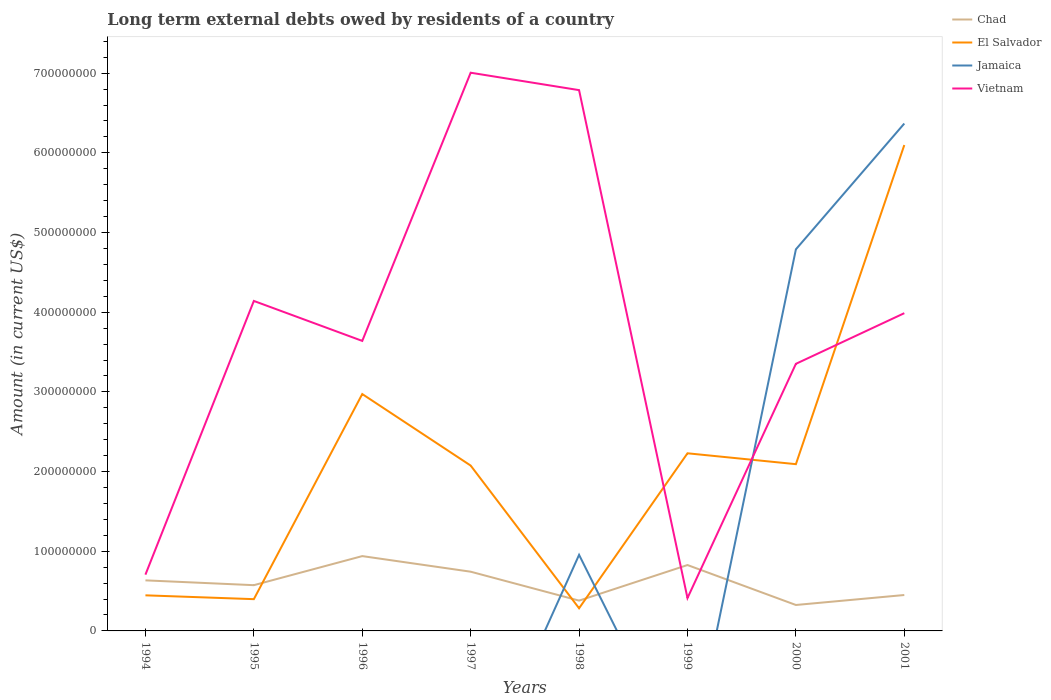How many different coloured lines are there?
Give a very brief answer. 4. Does the line corresponding to Jamaica intersect with the line corresponding to Chad?
Your answer should be very brief. Yes. Is the number of lines equal to the number of legend labels?
Keep it short and to the point. No. What is the total amount of long-term external debts owed by residents in El Salvador in the graph?
Your answer should be very brief. 7.43e+07. What is the difference between the highest and the second highest amount of long-term external debts owed by residents in Vietnam?
Provide a succinct answer. 6.59e+08. Is the amount of long-term external debts owed by residents in Jamaica strictly greater than the amount of long-term external debts owed by residents in El Salvador over the years?
Your answer should be compact. No. How many lines are there?
Offer a terse response. 4. How many years are there in the graph?
Offer a very short reply. 8. What is the difference between two consecutive major ticks on the Y-axis?
Your answer should be very brief. 1.00e+08. Does the graph contain any zero values?
Offer a terse response. Yes. Does the graph contain grids?
Make the answer very short. No. How are the legend labels stacked?
Make the answer very short. Vertical. What is the title of the graph?
Offer a terse response. Long term external debts owed by residents of a country. Does "Macedonia" appear as one of the legend labels in the graph?
Your answer should be very brief. No. What is the Amount (in current US$) of Chad in 1994?
Your answer should be very brief. 6.35e+07. What is the Amount (in current US$) in El Salvador in 1994?
Offer a very short reply. 4.47e+07. What is the Amount (in current US$) in Vietnam in 1994?
Offer a terse response. 7.06e+07. What is the Amount (in current US$) of Chad in 1995?
Your answer should be very brief. 5.74e+07. What is the Amount (in current US$) of El Salvador in 1995?
Your answer should be very brief. 3.99e+07. What is the Amount (in current US$) in Jamaica in 1995?
Provide a short and direct response. 0. What is the Amount (in current US$) in Vietnam in 1995?
Your response must be concise. 4.14e+08. What is the Amount (in current US$) of Chad in 1996?
Keep it short and to the point. 9.39e+07. What is the Amount (in current US$) of El Salvador in 1996?
Offer a very short reply. 2.97e+08. What is the Amount (in current US$) in Jamaica in 1996?
Your response must be concise. 0. What is the Amount (in current US$) in Vietnam in 1996?
Make the answer very short. 3.64e+08. What is the Amount (in current US$) of Chad in 1997?
Ensure brevity in your answer.  7.43e+07. What is the Amount (in current US$) of El Salvador in 1997?
Keep it short and to the point. 2.08e+08. What is the Amount (in current US$) in Vietnam in 1997?
Your answer should be compact. 7.01e+08. What is the Amount (in current US$) of Chad in 1998?
Your response must be concise. 3.80e+07. What is the Amount (in current US$) in El Salvador in 1998?
Ensure brevity in your answer.  2.84e+07. What is the Amount (in current US$) in Jamaica in 1998?
Provide a short and direct response. 9.55e+07. What is the Amount (in current US$) of Vietnam in 1998?
Provide a short and direct response. 6.79e+08. What is the Amount (in current US$) of Chad in 1999?
Keep it short and to the point. 8.27e+07. What is the Amount (in current US$) of El Salvador in 1999?
Provide a short and direct response. 2.23e+08. What is the Amount (in current US$) of Jamaica in 1999?
Provide a succinct answer. 0. What is the Amount (in current US$) of Vietnam in 1999?
Your answer should be compact. 4.12e+07. What is the Amount (in current US$) of Chad in 2000?
Give a very brief answer. 3.26e+07. What is the Amount (in current US$) in El Salvador in 2000?
Offer a terse response. 2.09e+08. What is the Amount (in current US$) in Jamaica in 2000?
Offer a terse response. 4.79e+08. What is the Amount (in current US$) in Vietnam in 2000?
Ensure brevity in your answer.  3.35e+08. What is the Amount (in current US$) of Chad in 2001?
Provide a short and direct response. 4.51e+07. What is the Amount (in current US$) of El Salvador in 2001?
Make the answer very short. 6.10e+08. What is the Amount (in current US$) in Jamaica in 2001?
Your response must be concise. 6.37e+08. What is the Amount (in current US$) of Vietnam in 2001?
Offer a terse response. 3.99e+08. Across all years, what is the maximum Amount (in current US$) of Chad?
Keep it short and to the point. 9.39e+07. Across all years, what is the maximum Amount (in current US$) of El Salvador?
Offer a terse response. 6.10e+08. Across all years, what is the maximum Amount (in current US$) in Jamaica?
Your answer should be very brief. 6.37e+08. Across all years, what is the maximum Amount (in current US$) of Vietnam?
Provide a succinct answer. 7.01e+08. Across all years, what is the minimum Amount (in current US$) of Chad?
Provide a short and direct response. 3.26e+07. Across all years, what is the minimum Amount (in current US$) in El Salvador?
Provide a succinct answer. 2.84e+07. Across all years, what is the minimum Amount (in current US$) in Vietnam?
Your answer should be very brief. 4.12e+07. What is the total Amount (in current US$) in Chad in the graph?
Provide a succinct answer. 4.87e+08. What is the total Amount (in current US$) in El Salvador in the graph?
Make the answer very short. 1.66e+09. What is the total Amount (in current US$) in Jamaica in the graph?
Offer a very short reply. 1.21e+09. What is the total Amount (in current US$) of Vietnam in the graph?
Offer a very short reply. 3.00e+09. What is the difference between the Amount (in current US$) in Chad in 1994 and that in 1995?
Provide a short and direct response. 6.05e+06. What is the difference between the Amount (in current US$) of El Salvador in 1994 and that in 1995?
Offer a terse response. 4.80e+06. What is the difference between the Amount (in current US$) of Vietnam in 1994 and that in 1995?
Provide a short and direct response. -3.43e+08. What is the difference between the Amount (in current US$) in Chad in 1994 and that in 1996?
Provide a short and direct response. -3.04e+07. What is the difference between the Amount (in current US$) in El Salvador in 1994 and that in 1996?
Your answer should be very brief. -2.53e+08. What is the difference between the Amount (in current US$) in Vietnam in 1994 and that in 1996?
Your answer should be compact. -2.93e+08. What is the difference between the Amount (in current US$) in Chad in 1994 and that in 1997?
Give a very brief answer. -1.09e+07. What is the difference between the Amount (in current US$) of El Salvador in 1994 and that in 1997?
Your answer should be very brief. -1.63e+08. What is the difference between the Amount (in current US$) of Vietnam in 1994 and that in 1997?
Offer a terse response. -6.30e+08. What is the difference between the Amount (in current US$) of Chad in 1994 and that in 1998?
Make the answer very short. 2.54e+07. What is the difference between the Amount (in current US$) of El Salvador in 1994 and that in 1998?
Make the answer very short. 1.62e+07. What is the difference between the Amount (in current US$) of Vietnam in 1994 and that in 1998?
Your answer should be very brief. -6.08e+08. What is the difference between the Amount (in current US$) of Chad in 1994 and that in 1999?
Provide a succinct answer. -1.92e+07. What is the difference between the Amount (in current US$) in El Salvador in 1994 and that in 1999?
Offer a very short reply. -1.78e+08. What is the difference between the Amount (in current US$) in Vietnam in 1994 and that in 1999?
Give a very brief answer. 2.94e+07. What is the difference between the Amount (in current US$) of Chad in 1994 and that in 2000?
Provide a short and direct response. 3.09e+07. What is the difference between the Amount (in current US$) of El Salvador in 1994 and that in 2000?
Make the answer very short. -1.65e+08. What is the difference between the Amount (in current US$) of Vietnam in 1994 and that in 2000?
Provide a short and direct response. -2.65e+08. What is the difference between the Amount (in current US$) in Chad in 1994 and that in 2001?
Offer a terse response. 1.84e+07. What is the difference between the Amount (in current US$) in El Salvador in 1994 and that in 2001?
Offer a very short reply. -5.65e+08. What is the difference between the Amount (in current US$) of Vietnam in 1994 and that in 2001?
Offer a very short reply. -3.28e+08. What is the difference between the Amount (in current US$) of Chad in 1995 and that in 1996?
Keep it short and to the point. -3.65e+07. What is the difference between the Amount (in current US$) in El Salvador in 1995 and that in 1996?
Give a very brief answer. -2.57e+08. What is the difference between the Amount (in current US$) in Vietnam in 1995 and that in 1996?
Ensure brevity in your answer.  5.02e+07. What is the difference between the Amount (in current US$) in Chad in 1995 and that in 1997?
Your answer should be very brief. -1.69e+07. What is the difference between the Amount (in current US$) of El Salvador in 1995 and that in 1997?
Your answer should be very brief. -1.68e+08. What is the difference between the Amount (in current US$) in Vietnam in 1995 and that in 1997?
Your answer should be very brief. -2.86e+08. What is the difference between the Amount (in current US$) of Chad in 1995 and that in 1998?
Offer a very short reply. 1.94e+07. What is the difference between the Amount (in current US$) of El Salvador in 1995 and that in 1998?
Your answer should be very brief. 1.14e+07. What is the difference between the Amount (in current US$) in Vietnam in 1995 and that in 1998?
Offer a terse response. -2.65e+08. What is the difference between the Amount (in current US$) of Chad in 1995 and that in 1999?
Provide a succinct answer. -2.53e+07. What is the difference between the Amount (in current US$) in El Salvador in 1995 and that in 1999?
Provide a succinct answer. -1.83e+08. What is the difference between the Amount (in current US$) in Vietnam in 1995 and that in 1999?
Offer a very short reply. 3.73e+08. What is the difference between the Amount (in current US$) of Chad in 1995 and that in 2000?
Provide a succinct answer. 2.49e+07. What is the difference between the Amount (in current US$) in El Salvador in 1995 and that in 2000?
Offer a terse response. -1.69e+08. What is the difference between the Amount (in current US$) in Vietnam in 1995 and that in 2000?
Offer a very short reply. 7.89e+07. What is the difference between the Amount (in current US$) of Chad in 1995 and that in 2001?
Your response must be concise. 1.24e+07. What is the difference between the Amount (in current US$) in El Salvador in 1995 and that in 2001?
Provide a short and direct response. -5.70e+08. What is the difference between the Amount (in current US$) of Vietnam in 1995 and that in 2001?
Offer a terse response. 1.54e+07. What is the difference between the Amount (in current US$) in Chad in 1996 and that in 1997?
Provide a succinct answer. 1.96e+07. What is the difference between the Amount (in current US$) of El Salvador in 1996 and that in 1997?
Provide a succinct answer. 8.98e+07. What is the difference between the Amount (in current US$) in Vietnam in 1996 and that in 1997?
Offer a very short reply. -3.37e+08. What is the difference between the Amount (in current US$) in Chad in 1996 and that in 1998?
Provide a short and direct response. 5.59e+07. What is the difference between the Amount (in current US$) of El Salvador in 1996 and that in 1998?
Your answer should be compact. 2.69e+08. What is the difference between the Amount (in current US$) of Vietnam in 1996 and that in 1998?
Your response must be concise. -3.15e+08. What is the difference between the Amount (in current US$) in Chad in 1996 and that in 1999?
Make the answer very short. 1.12e+07. What is the difference between the Amount (in current US$) in El Salvador in 1996 and that in 1999?
Give a very brief answer. 7.43e+07. What is the difference between the Amount (in current US$) in Vietnam in 1996 and that in 1999?
Give a very brief answer. 3.23e+08. What is the difference between the Amount (in current US$) in Chad in 1996 and that in 2000?
Your answer should be compact. 6.13e+07. What is the difference between the Amount (in current US$) in El Salvador in 1996 and that in 2000?
Give a very brief answer. 8.80e+07. What is the difference between the Amount (in current US$) in Vietnam in 1996 and that in 2000?
Offer a very short reply. 2.88e+07. What is the difference between the Amount (in current US$) in Chad in 1996 and that in 2001?
Provide a short and direct response. 4.88e+07. What is the difference between the Amount (in current US$) of El Salvador in 1996 and that in 2001?
Ensure brevity in your answer.  -3.13e+08. What is the difference between the Amount (in current US$) of Vietnam in 1996 and that in 2001?
Ensure brevity in your answer.  -3.48e+07. What is the difference between the Amount (in current US$) of Chad in 1997 and that in 1998?
Your answer should be compact. 3.63e+07. What is the difference between the Amount (in current US$) of El Salvador in 1997 and that in 1998?
Your response must be concise. 1.79e+08. What is the difference between the Amount (in current US$) in Vietnam in 1997 and that in 1998?
Your answer should be compact. 2.19e+07. What is the difference between the Amount (in current US$) of Chad in 1997 and that in 1999?
Offer a terse response. -8.35e+06. What is the difference between the Amount (in current US$) in El Salvador in 1997 and that in 1999?
Keep it short and to the point. -1.54e+07. What is the difference between the Amount (in current US$) of Vietnam in 1997 and that in 1999?
Offer a terse response. 6.59e+08. What is the difference between the Amount (in current US$) in Chad in 1997 and that in 2000?
Your answer should be compact. 4.18e+07. What is the difference between the Amount (in current US$) of El Salvador in 1997 and that in 2000?
Your answer should be compact. -1.77e+06. What is the difference between the Amount (in current US$) of Vietnam in 1997 and that in 2000?
Provide a succinct answer. 3.65e+08. What is the difference between the Amount (in current US$) of Chad in 1997 and that in 2001?
Your answer should be very brief. 2.93e+07. What is the difference between the Amount (in current US$) in El Salvador in 1997 and that in 2001?
Offer a terse response. -4.02e+08. What is the difference between the Amount (in current US$) in Vietnam in 1997 and that in 2001?
Offer a terse response. 3.02e+08. What is the difference between the Amount (in current US$) of Chad in 1998 and that in 1999?
Offer a very short reply. -4.47e+07. What is the difference between the Amount (in current US$) of El Salvador in 1998 and that in 1999?
Offer a terse response. -1.95e+08. What is the difference between the Amount (in current US$) in Vietnam in 1998 and that in 1999?
Offer a terse response. 6.37e+08. What is the difference between the Amount (in current US$) of Chad in 1998 and that in 2000?
Make the answer very short. 5.48e+06. What is the difference between the Amount (in current US$) of El Salvador in 1998 and that in 2000?
Provide a succinct answer. -1.81e+08. What is the difference between the Amount (in current US$) of Jamaica in 1998 and that in 2000?
Offer a terse response. -3.83e+08. What is the difference between the Amount (in current US$) in Vietnam in 1998 and that in 2000?
Offer a very short reply. 3.43e+08. What is the difference between the Amount (in current US$) of Chad in 1998 and that in 2001?
Your answer should be compact. -7.03e+06. What is the difference between the Amount (in current US$) in El Salvador in 1998 and that in 2001?
Ensure brevity in your answer.  -5.81e+08. What is the difference between the Amount (in current US$) in Jamaica in 1998 and that in 2001?
Your answer should be compact. -5.41e+08. What is the difference between the Amount (in current US$) of Vietnam in 1998 and that in 2001?
Provide a short and direct response. 2.80e+08. What is the difference between the Amount (in current US$) in Chad in 1999 and that in 2000?
Keep it short and to the point. 5.01e+07. What is the difference between the Amount (in current US$) in El Salvador in 1999 and that in 2000?
Keep it short and to the point. 1.37e+07. What is the difference between the Amount (in current US$) of Vietnam in 1999 and that in 2000?
Offer a terse response. -2.94e+08. What is the difference between the Amount (in current US$) of Chad in 1999 and that in 2001?
Provide a succinct answer. 3.76e+07. What is the difference between the Amount (in current US$) in El Salvador in 1999 and that in 2001?
Give a very brief answer. -3.87e+08. What is the difference between the Amount (in current US$) of Vietnam in 1999 and that in 2001?
Keep it short and to the point. -3.58e+08. What is the difference between the Amount (in current US$) in Chad in 2000 and that in 2001?
Offer a terse response. -1.25e+07. What is the difference between the Amount (in current US$) of El Salvador in 2000 and that in 2001?
Your response must be concise. -4.01e+08. What is the difference between the Amount (in current US$) in Jamaica in 2000 and that in 2001?
Give a very brief answer. -1.58e+08. What is the difference between the Amount (in current US$) in Vietnam in 2000 and that in 2001?
Give a very brief answer. -6.36e+07. What is the difference between the Amount (in current US$) of Chad in 1994 and the Amount (in current US$) of El Salvador in 1995?
Ensure brevity in your answer.  2.36e+07. What is the difference between the Amount (in current US$) in Chad in 1994 and the Amount (in current US$) in Vietnam in 1995?
Offer a terse response. -3.51e+08. What is the difference between the Amount (in current US$) in El Salvador in 1994 and the Amount (in current US$) in Vietnam in 1995?
Your answer should be very brief. -3.69e+08. What is the difference between the Amount (in current US$) of Chad in 1994 and the Amount (in current US$) of El Salvador in 1996?
Your response must be concise. -2.34e+08. What is the difference between the Amount (in current US$) in Chad in 1994 and the Amount (in current US$) in Vietnam in 1996?
Keep it short and to the point. -3.01e+08. What is the difference between the Amount (in current US$) of El Salvador in 1994 and the Amount (in current US$) of Vietnam in 1996?
Offer a terse response. -3.19e+08. What is the difference between the Amount (in current US$) of Chad in 1994 and the Amount (in current US$) of El Salvador in 1997?
Your response must be concise. -1.44e+08. What is the difference between the Amount (in current US$) of Chad in 1994 and the Amount (in current US$) of Vietnam in 1997?
Your answer should be very brief. -6.37e+08. What is the difference between the Amount (in current US$) in El Salvador in 1994 and the Amount (in current US$) in Vietnam in 1997?
Offer a very short reply. -6.56e+08. What is the difference between the Amount (in current US$) in Chad in 1994 and the Amount (in current US$) in El Salvador in 1998?
Provide a succinct answer. 3.50e+07. What is the difference between the Amount (in current US$) of Chad in 1994 and the Amount (in current US$) of Jamaica in 1998?
Give a very brief answer. -3.20e+07. What is the difference between the Amount (in current US$) of Chad in 1994 and the Amount (in current US$) of Vietnam in 1998?
Your answer should be compact. -6.15e+08. What is the difference between the Amount (in current US$) in El Salvador in 1994 and the Amount (in current US$) in Jamaica in 1998?
Offer a terse response. -5.08e+07. What is the difference between the Amount (in current US$) in El Salvador in 1994 and the Amount (in current US$) in Vietnam in 1998?
Offer a very short reply. -6.34e+08. What is the difference between the Amount (in current US$) in Chad in 1994 and the Amount (in current US$) in El Salvador in 1999?
Offer a very short reply. -1.59e+08. What is the difference between the Amount (in current US$) in Chad in 1994 and the Amount (in current US$) in Vietnam in 1999?
Your answer should be very brief. 2.22e+07. What is the difference between the Amount (in current US$) of El Salvador in 1994 and the Amount (in current US$) of Vietnam in 1999?
Offer a terse response. 3.43e+06. What is the difference between the Amount (in current US$) of Chad in 1994 and the Amount (in current US$) of El Salvador in 2000?
Provide a succinct answer. -1.46e+08. What is the difference between the Amount (in current US$) of Chad in 1994 and the Amount (in current US$) of Jamaica in 2000?
Provide a short and direct response. -4.15e+08. What is the difference between the Amount (in current US$) of Chad in 1994 and the Amount (in current US$) of Vietnam in 2000?
Ensure brevity in your answer.  -2.72e+08. What is the difference between the Amount (in current US$) in El Salvador in 1994 and the Amount (in current US$) in Jamaica in 2000?
Keep it short and to the point. -4.34e+08. What is the difference between the Amount (in current US$) in El Salvador in 1994 and the Amount (in current US$) in Vietnam in 2000?
Offer a very short reply. -2.91e+08. What is the difference between the Amount (in current US$) of Chad in 1994 and the Amount (in current US$) of El Salvador in 2001?
Your response must be concise. -5.46e+08. What is the difference between the Amount (in current US$) of Chad in 1994 and the Amount (in current US$) of Jamaica in 2001?
Make the answer very short. -5.73e+08. What is the difference between the Amount (in current US$) in Chad in 1994 and the Amount (in current US$) in Vietnam in 2001?
Keep it short and to the point. -3.35e+08. What is the difference between the Amount (in current US$) of El Salvador in 1994 and the Amount (in current US$) of Jamaica in 2001?
Your response must be concise. -5.92e+08. What is the difference between the Amount (in current US$) of El Salvador in 1994 and the Amount (in current US$) of Vietnam in 2001?
Ensure brevity in your answer.  -3.54e+08. What is the difference between the Amount (in current US$) in Chad in 1995 and the Amount (in current US$) in El Salvador in 1996?
Offer a very short reply. -2.40e+08. What is the difference between the Amount (in current US$) in Chad in 1995 and the Amount (in current US$) in Vietnam in 1996?
Provide a short and direct response. -3.07e+08. What is the difference between the Amount (in current US$) of El Salvador in 1995 and the Amount (in current US$) of Vietnam in 1996?
Provide a short and direct response. -3.24e+08. What is the difference between the Amount (in current US$) of Chad in 1995 and the Amount (in current US$) of El Salvador in 1997?
Ensure brevity in your answer.  -1.50e+08. What is the difference between the Amount (in current US$) in Chad in 1995 and the Amount (in current US$) in Vietnam in 1997?
Provide a short and direct response. -6.43e+08. What is the difference between the Amount (in current US$) in El Salvador in 1995 and the Amount (in current US$) in Vietnam in 1997?
Your answer should be very brief. -6.61e+08. What is the difference between the Amount (in current US$) in Chad in 1995 and the Amount (in current US$) in El Salvador in 1998?
Keep it short and to the point. 2.90e+07. What is the difference between the Amount (in current US$) of Chad in 1995 and the Amount (in current US$) of Jamaica in 1998?
Offer a terse response. -3.81e+07. What is the difference between the Amount (in current US$) in Chad in 1995 and the Amount (in current US$) in Vietnam in 1998?
Offer a very short reply. -6.21e+08. What is the difference between the Amount (in current US$) in El Salvador in 1995 and the Amount (in current US$) in Jamaica in 1998?
Your answer should be very brief. -5.56e+07. What is the difference between the Amount (in current US$) in El Salvador in 1995 and the Amount (in current US$) in Vietnam in 1998?
Make the answer very short. -6.39e+08. What is the difference between the Amount (in current US$) of Chad in 1995 and the Amount (in current US$) of El Salvador in 1999?
Your answer should be compact. -1.66e+08. What is the difference between the Amount (in current US$) of Chad in 1995 and the Amount (in current US$) of Vietnam in 1999?
Offer a terse response. 1.62e+07. What is the difference between the Amount (in current US$) of El Salvador in 1995 and the Amount (in current US$) of Vietnam in 1999?
Provide a short and direct response. -1.37e+06. What is the difference between the Amount (in current US$) of Chad in 1995 and the Amount (in current US$) of El Salvador in 2000?
Your answer should be compact. -1.52e+08. What is the difference between the Amount (in current US$) of Chad in 1995 and the Amount (in current US$) of Jamaica in 2000?
Provide a short and direct response. -4.21e+08. What is the difference between the Amount (in current US$) in Chad in 1995 and the Amount (in current US$) in Vietnam in 2000?
Provide a short and direct response. -2.78e+08. What is the difference between the Amount (in current US$) in El Salvador in 1995 and the Amount (in current US$) in Jamaica in 2000?
Provide a short and direct response. -4.39e+08. What is the difference between the Amount (in current US$) of El Salvador in 1995 and the Amount (in current US$) of Vietnam in 2000?
Make the answer very short. -2.95e+08. What is the difference between the Amount (in current US$) of Chad in 1995 and the Amount (in current US$) of El Salvador in 2001?
Offer a very short reply. -5.52e+08. What is the difference between the Amount (in current US$) of Chad in 1995 and the Amount (in current US$) of Jamaica in 2001?
Your response must be concise. -5.79e+08. What is the difference between the Amount (in current US$) of Chad in 1995 and the Amount (in current US$) of Vietnam in 2001?
Provide a succinct answer. -3.41e+08. What is the difference between the Amount (in current US$) in El Salvador in 1995 and the Amount (in current US$) in Jamaica in 2001?
Provide a succinct answer. -5.97e+08. What is the difference between the Amount (in current US$) of El Salvador in 1995 and the Amount (in current US$) of Vietnam in 2001?
Provide a short and direct response. -3.59e+08. What is the difference between the Amount (in current US$) of Chad in 1996 and the Amount (in current US$) of El Salvador in 1997?
Offer a very short reply. -1.14e+08. What is the difference between the Amount (in current US$) of Chad in 1996 and the Amount (in current US$) of Vietnam in 1997?
Provide a succinct answer. -6.07e+08. What is the difference between the Amount (in current US$) of El Salvador in 1996 and the Amount (in current US$) of Vietnam in 1997?
Offer a very short reply. -4.03e+08. What is the difference between the Amount (in current US$) in Chad in 1996 and the Amount (in current US$) in El Salvador in 1998?
Ensure brevity in your answer.  6.55e+07. What is the difference between the Amount (in current US$) of Chad in 1996 and the Amount (in current US$) of Jamaica in 1998?
Keep it short and to the point. -1.56e+06. What is the difference between the Amount (in current US$) in Chad in 1996 and the Amount (in current US$) in Vietnam in 1998?
Make the answer very short. -5.85e+08. What is the difference between the Amount (in current US$) in El Salvador in 1996 and the Amount (in current US$) in Jamaica in 1998?
Keep it short and to the point. 2.02e+08. What is the difference between the Amount (in current US$) in El Salvador in 1996 and the Amount (in current US$) in Vietnam in 1998?
Your answer should be compact. -3.81e+08. What is the difference between the Amount (in current US$) in Chad in 1996 and the Amount (in current US$) in El Salvador in 1999?
Provide a succinct answer. -1.29e+08. What is the difference between the Amount (in current US$) of Chad in 1996 and the Amount (in current US$) of Vietnam in 1999?
Give a very brief answer. 5.27e+07. What is the difference between the Amount (in current US$) of El Salvador in 1996 and the Amount (in current US$) of Vietnam in 1999?
Your answer should be very brief. 2.56e+08. What is the difference between the Amount (in current US$) in Chad in 1996 and the Amount (in current US$) in El Salvador in 2000?
Make the answer very short. -1.15e+08. What is the difference between the Amount (in current US$) of Chad in 1996 and the Amount (in current US$) of Jamaica in 2000?
Keep it short and to the point. -3.85e+08. What is the difference between the Amount (in current US$) in Chad in 1996 and the Amount (in current US$) in Vietnam in 2000?
Ensure brevity in your answer.  -2.41e+08. What is the difference between the Amount (in current US$) in El Salvador in 1996 and the Amount (in current US$) in Jamaica in 2000?
Give a very brief answer. -1.82e+08. What is the difference between the Amount (in current US$) in El Salvador in 1996 and the Amount (in current US$) in Vietnam in 2000?
Ensure brevity in your answer.  -3.79e+07. What is the difference between the Amount (in current US$) in Chad in 1996 and the Amount (in current US$) in El Salvador in 2001?
Your answer should be very brief. -5.16e+08. What is the difference between the Amount (in current US$) in Chad in 1996 and the Amount (in current US$) in Jamaica in 2001?
Your response must be concise. -5.43e+08. What is the difference between the Amount (in current US$) of Chad in 1996 and the Amount (in current US$) of Vietnam in 2001?
Offer a terse response. -3.05e+08. What is the difference between the Amount (in current US$) in El Salvador in 1996 and the Amount (in current US$) in Jamaica in 2001?
Your answer should be compact. -3.40e+08. What is the difference between the Amount (in current US$) in El Salvador in 1996 and the Amount (in current US$) in Vietnam in 2001?
Your answer should be compact. -1.02e+08. What is the difference between the Amount (in current US$) of Chad in 1997 and the Amount (in current US$) of El Salvador in 1998?
Your response must be concise. 4.59e+07. What is the difference between the Amount (in current US$) of Chad in 1997 and the Amount (in current US$) of Jamaica in 1998?
Provide a succinct answer. -2.11e+07. What is the difference between the Amount (in current US$) of Chad in 1997 and the Amount (in current US$) of Vietnam in 1998?
Ensure brevity in your answer.  -6.04e+08. What is the difference between the Amount (in current US$) in El Salvador in 1997 and the Amount (in current US$) in Jamaica in 1998?
Provide a succinct answer. 1.12e+08. What is the difference between the Amount (in current US$) of El Salvador in 1997 and the Amount (in current US$) of Vietnam in 1998?
Your answer should be compact. -4.71e+08. What is the difference between the Amount (in current US$) of Chad in 1997 and the Amount (in current US$) of El Salvador in 1999?
Offer a very short reply. -1.49e+08. What is the difference between the Amount (in current US$) in Chad in 1997 and the Amount (in current US$) in Vietnam in 1999?
Keep it short and to the point. 3.31e+07. What is the difference between the Amount (in current US$) in El Salvador in 1997 and the Amount (in current US$) in Vietnam in 1999?
Your answer should be very brief. 1.66e+08. What is the difference between the Amount (in current US$) of Chad in 1997 and the Amount (in current US$) of El Salvador in 2000?
Your answer should be very brief. -1.35e+08. What is the difference between the Amount (in current US$) of Chad in 1997 and the Amount (in current US$) of Jamaica in 2000?
Provide a short and direct response. -4.05e+08. What is the difference between the Amount (in current US$) in Chad in 1997 and the Amount (in current US$) in Vietnam in 2000?
Offer a terse response. -2.61e+08. What is the difference between the Amount (in current US$) of El Salvador in 1997 and the Amount (in current US$) of Jamaica in 2000?
Provide a short and direct response. -2.71e+08. What is the difference between the Amount (in current US$) of El Salvador in 1997 and the Amount (in current US$) of Vietnam in 2000?
Provide a succinct answer. -1.28e+08. What is the difference between the Amount (in current US$) in Chad in 1997 and the Amount (in current US$) in El Salvador in 2001?
Offer a very short reply. -5.35e+08. What is the difference between the Amount (in current US$) in Chad in 1997 and the Amount (in current US$) in Jamaica in 2001?
Provide a short and direct response. -5.62e+08. What is the difference between the Amount (in current US$) of Chad in 1997 and the Amount (in current US$) of Vietnam in 2001?
Offer a terse response. -3.24e+08. What is the difference between the Amount (in current US$) in El Salvador in 1997 and the Amount (in current US$) in Jamaica in 2001?
Keep it short and to the point. -4.29e+08. What is the difference between the Amount (in current US$) of El Salvador in 1997 and the Amount (in current US$) of Vietnam in 2001?
Your response must be concise. -1.91e+08. What is the difference between the Amount (in current US$) of Chad in 1998 and the Amount (in current US$) of El Salvador in 1999?
Offer a very short reply. -1.85e+08. What is the difference between the Amount (in current US$) of Chad in 1998 and the Amount (in current US$) of Vietnam in 1999?
Ensure brevity in your answer.  -3.20e+06. What is the difference between the Amount (in current US$) of El Salvador in 1998 and the Amount (in current US$) of Vietnam in 1999?
Offer a terse response. -1.28e+07. What is the difference between the Amount (in current US$) of Jamaica in 1998 and the Amount (in current US$) of Vietnam in 1999?
Offer a terse response. 5.42e+07. What is the difference between the Amount (in current US$) in Chad in 1998 and the Amount (in current US$) in El Salvador in 2000?
Provide a succinct answer. -1.71e+08. What is the difference between the Amount (in current US$) of Chad in 1998 and the Amount (in current US$) of Jamaica in 2000?
Provide a short and direct response. -4.41e+08. What is the difference between the Amount (in current US$) of Chad in 1998 and the Amount (in current US$) of Vietnam in 2000?
Make the answer very short. -2.97e+08. What is the difference between the Amount (in current US$) in El Salvador in 1998 and the Amount (in current US$) in Jamaica in 2000?
Offer a terse response. -4.50e+08. What is the difference between the Amount (in current US$) in El Salvador in 1998 and the Amount (in current US$) in Vietnam in 2000?
Provide a short and direct response. -3.07e+08. What is the difference between the Amount (in current US$) in Jamaica in 1998 and the Amount (in current US$) in Vietnam in 2000?
Your answer should be very brief. -2.40e+08. What is the difference between the Amount (in current US$) of Chad in 1998 and the Amount (in current US$) of El Salvador in 2001?
Provide a short and direct response. -5.72e+08. What is the difference between the Amount (in current US$) in Chad in 1998 and the Amount (in current US$) in Jamaica in 2001?
Provide a short and direct response. -5.99e+08. What is the difference between the Amount (in current US$) of Chad in 1998 and the Amount (in current US$) of Vietnam in 2001?
Offer a very short reply. -3.61e+08. What is the difference between the Amount (in current US$) in El Salvador in 1998 and the Amount (in current US$) in Jamaica in 2001?
Provide a succinct answer. -6.08e+08. What is the difference between the Amount (in current US$) in El Salvador in 1998 and the Amount (in current US$) in Vietnam in 2001?
Make the answer very short. -3.70e+08. What is the difference between the Amount (in current US$) of Jamaica in 1998 and the Amount (in current US$) of Vietnam in 2001?
Ensure brevity in your answer.  -3.03e+08. What is the difference between the Amount (in current US$) of Chad in 1999 and the Amount (in current US$) of El Salvador in 2000?
Give a very brief answer. -1.27e+08. What is the difference between the Amount (in current US$) in Chad in 1999 and the Amount (in current US$) in Jamaica in 2000?
Make the answer very short. -3.96e+08. What is the difference between the Amount (in current US$) of Chad in 1999 and the Amount (in current US$) of Vietnam in 2000?
Offer a terse response. -2.53e+08. What is the difference between the Amount (in current US$) in El Salvador in 1999 and the Amount (in current US$) in Jamaica in 2000?
Give a very brief answer. -2.56e+08. What is the difference between the Amount (in current US$) in El Salvador in 1999 and the Amount (in current US$) in Vietnam in 2000?
Your response must be concise. -1.12e+08. What is the difference between the Amount (in current US$) in Chad in 1999 and the Amount (in current US$) in El Salvador in 2001?
Keep it short and to the point. -5.27e+08. What is the difference between the Amount (in current US$) in Chad in 1999 and the Amount (in current US$) in Jamaica in 2001?
Your response must be concise. -5.54e+08. What is the difference between the Amount (in current US$) of Chad in 1999 and the Amount (in current US$) of Vietnam in 2001?
Provide a succinct answer. -3.16e+08. What is the difference between the Amount (in current US$) in El Salvador in 1999 and the Amount (in current US$) in Jamaica in 2001?
Offer a terse response. -4.14e+08. What is the difference between the Amount (in current US$) in El Salvador in 1999 and the Amount (in current US$) in Vietnam in 2001?
Offer a very short reply. -1.76e+08. What is the difference between the Amount (in current US$) of Chad in 2000 and the Amount (in current US$) of El Salvador in 2001?
Offer a terse response. -5.77e+08. What is the difference between the Amount (in current US$) of Chad in 2000 and the Amount (in current US$) of Jamaica in 2001?
Give a very brief answer. -6.04e+08. What is the difference between the Amount (in current US$) of Chad in 2000 and the Amount (in current US$) of Vietnam in 2001?
Offer a terse response. -3.66e+08. What is the difference between the Amount (in current US$) in El Salvador in 2000 and the Amount (in current US$) in Jamaica in 2001?
Offer a terse response. -4.28e+08. What is the difference between the Amount (in current US$) in El Salvador in 2000 and the Amount (in current US$) in Vietnam in 2001?
Provide a short and direct response. -1.90e+08. What is the difference between the Amount (in current US$) in Jamaica in 2000 and the Amount (in current US$) in Vietnam in 2001?
Your response must be concise. 8.01e+07. What is the average Amount (in current US$) in Chad per year?
Provide a succinct answer. 6.09e+07. What is the average Amount (in current US$) in El Salvador per year?
Keep it short and to the point. 2.07e+08. What is the average Amount (in current US$) of Jamaica per year?
Your answer should be very brief. 1.51e+08. What is the average Amount (in current US$) in Vietnam per year?
Your response must be concise. 3.75e+08. In the year 1994, what is the difference between the Amount (in current US$) of Chad and Amount (in current US$) of El Salvador?
Provide a succinct answer. 1.88e+07. In the year 1994, what is the difference between the Amount (in current US$) in Chad and Amount (in current US$) in Vietnam?
Your answer should be very brief. -7.17e+06. In the year 1994, what is the difference between the Amount (in current US$) of El Salvador and Amount (in current US$) of Vietnam?
Give a very brief answer. -2.60e+07. In the year 1995, what is the difference between the Amount (in current US$) of Chad and Amount (in current US$) of El Salvador?
Offer a terse response. 1.75e+07. In the year 1995, what is the difference between the Amount (in current US$) of Chad and Amount (in current US$) of Vietnam?
Provide a short and direct response. -3.57e+08. In the year 1995, what is the difference between the Amount (in current US$) of El Salvador and Amount (in current US$) of Vietnam?
Offer a very short reply. -3.74e+08. In the year 1996, what is the difference between the Amount (in current US$) of Chad and Amount (in current US$) of El Salvador?
Your answer should be very brief. -2.03e+08. In the year 1996, what is the difference between the Amount (in current US$) in Chad and Amount (in current US$) in Vietnam?
Your answer should be very brief. -2.70e+08. In the year 1996, what is the difference between the Amount (in current US$) of El Salvador and Amount (in current US$) of Vietnam?
Provide a succinct answer. -6.67e+07. In the year 1997, what is the difference between the Amount (in current US$) in Chad and Amount (in current US$) in El Salvador?
Offer a terse response. -1.33e+08. In the year 1997, what is the difference between the Amount (in current US$) of Chad and Amount (in current US$) of Vietnam?
Offer a terse response. -6.26e+08. In the year 1997, what is the difference between the Amount (in current US$) in El Salvador and Amount (in current US$) in Vietnam?
Keep it short and to the point. -4.93e+08. In the year 1998, what is the difference between the Amount (in current US$) of Chad and Amount (in current US$) of El Salvador?
Ensure brevity in your answer.  9.61e+06. In the year 1998, what is the difference between the Amount (in current US$) of Chad and Amount (in current US$) of Jamaica?
Your answer should be compact. -5.74e+07. In the year 1998, what is the difference between the Amount (in current US$) of Chad and Amount (in current US$) of Vietnam?
Your answer should be compact. -6.41e+08. In the year 1998, what is the difference between the Amount (in current US$) of El Salvador and Amount (in current US$) of Jamaica?
Offer a terse response. -6.70e+07. In the year 1998, what is the difference between the Amount (in current US$) of El Salvador and Amount (in current US$) of Vietnam?
Your response must be concise. -6.50e+08. In the year 1998, what is the difference between the Amount (in current US$) in Jamaica and Amount (in current US$) in Vietnam?
Make the answer very short. -5.83e+08. In the year 1999, what is the difference between the Amount (in current US$) in Chad and Amount (in current US$) in El Salvador?
Your response must be concise. -1.40e+08. In the year 1999, what is the difference between the Amount (in current US$) of Chad and Amount (in current US$) of Vietnam?
Provide a short and direct response. 4.14e+07. In the year 1999, what is the difference between the Amount (in current US$) of El Salvador and Amount (in current US$) of Vietnam?
Make the answer very short. 1.82e+08. In the year 2000, what is the difference between the Amount (in current US$) of Chad and Amount (in current US$) of El Salvador?
Provide a succinct answer. -1.77e+08. In the year 2000, what is the difference between the Amount (in current US$) in Chad and Amount (in current US$) in Jamaica?
Provide a short and direct response. -4.46e+08. In the year 2000, what is the difference between the Amount (in current US$) of Chad and Amount (in current US$) of Vietnam?
Provide a short and direct response. -3.03e+08. In the year 2000, what is the difference between the Amount (in current US$) of El Salvador and Amount (in current US$) of Jamaica?
Your response must be concise. -2.70e+08. In the year 2000, what is the difference between the Amount (in current US$) of El Salvador and Amount (in current US$) of Vietnam?
Give a very brief answer. -1.26e+08. In the year 2000, what is the difference between the Amount (in current US$) in Jamaica and Amount (in current US$) in Vietnam?
Give a very brief answer. 1.44e+08. In the year 2001, what is the difference between the Amount (in current US$) of Chad and Amount (in current US$) of El Salvador?
Offer a terse response. -5.65e+08. In the year 2001, what is the difference between the Amount (in current US$) in Chad and Amount (in current US$) in Jamaica?
Offer a terse response. -5.92e+08. In the year 2001, what is the difference between the Amount (in current US$) of Chad and Amount (in current US$) of Vietnam?
Make the answer very short. -3.54e+08. In the year 2001, what is the difference between the Amount (in current US$) in El Salvador and Amount (in current US$) in Jamaica?
Ensure brevity in your answer.  -2.70e+07. In the year 2001, what is the difference between the Amount (in current US$) of El Salvador and Amount (in current US$) of Vietnam?
Provide a succinct answer. 2.11e+08. In the year 2001, what is the difference between the Amount (in current US$) of Jamaica and Amount (in current US$) of Vietnam?
Offer a terse response. 2.38e+08. What is the ratio of the Amount (in current US$) of Chad in 1994 to that in 1995?
Your answer should be compact. 1.11. What is the ratio of the Amount (in current US$) of El Salvador in 1994 to that in 1995?
Your answer should be compact. 1.12. What is the ratio of the Amount (in current US$) in Vietnam in 1994 to that in 1995?
Offer a terse response. 0.17. What is the ratio of the Amount (in current US$) of Chad in 1994 to that in 1996?
Offer a terse response. 0.68. What is the ratio of the Amount (in current US$) in El Salvador in 1994 to that in 1996?
Offer a terse response. 0.15. What is the ratio of the Amount (in current US$) of Vietnam in 1994 to that in 1996?
Keep it short and to the point. 0.19. What is the ratio of the Amount (in current US$) of Chad in 1994 to that in 1997?
Offer a very short reply. 0.85. What is the ratio of the Amount (in current US$) in El Salvador in 1994 to that in 1997?
Provide a short and direct response. 0.22. What is the ratio of the Amount (in current US$) of Vietnam in 1994 to that in 1997?
Offer a terse response. 0.1. What is the ratio of the Amount (in current US$) in Chad in 1994 to that in 1998?
Your response must be concise. 1.67. What is the ratio of the Amount (in current US$) in El Salvador in 1994 to that in 1998?
Your response must be concise. 1.57. What is the ratio of the Amount (in current US$) in Vietnam in 1994 to that in 1998?
Provide a short and direct response. 0.1. What is the ratio of the Amount (in current US$) of Chad in 1994 to that in 1999?
Provide a succinct answer. 0.77. What is the ratio of the Amount (in current US$) of El Salvador in 1994 to that in 1999?
Offer a very short reply. 0.2. What is the ratio of the Amount (in current US$) in Vietnam in 1994 to that in 1999?
Your response must be concise. 1.71. What is the ratio of the Amount (in current US$) of Chad in 1994 to that in 2000?
Make the answer very short. 1.95. What is the ratio of the Amount (in current US$) in El Salvador in 1994 to that in 2000?
Your answer should be very brief. 0.21. What is the ratio of the Amount (in current US$) of Vietnam in 1994 to that in 2000?
Provide a short and direct response. 0.21. What is the ratio of the Amount (in current US$) of Chad in 1994 to that in 2001?
Provide a succinct answer. 1.41. What is the ratio of the Amount (in current US$) of El Salvador in 1994 to that in 2001?
Offer a terse response. 0.07. What is the ratio of the Amount (in current US$) in Vietnam in 1994 to that in 2001?
Offer a very short reply. 0.18. What is the ratio of the Amount (in current US$) in Chad in 1995 to that in 1996?
Make the answer very short. 0.61. What is the ratio of the Amount (in current US$) in El Salvador in 1995 to that in 1996?
Make the answer very short. 0.13. What is the ratio of the Amount (in current US$) of Vietnam in 1995 to that in 1996?
Provide a succinct answer. 1.14. What is the ratio of the Amount (in current US$) of Chad in 1995 to that in 1997?
Ensure brevity in your answer.  0.77. What is the ratio of the Amount (in current US$) of El Salvador in 1995 to that in 1997?
Give a very brief answer. 0.19. What is the ratio of the Amount (in current US$) in Vietnam in 1995 to that in 1997?
Your answer should be compact. 0.59. What is the ratio of the Amount (in current US$) in Chad in 1995 to that in 1998?
Your answer should be very brief. 1.51. What is the ratio of the Amount (in current US$) in El Salvador in 1995 to that in 1998?
Provide a succinct answer. 1.4. What is the ratio of the Amount (in current US$) in Vietnam in 1995 to that in 1998?
Make the answer very short. 0.61. What is the ratio of the Amount (in current US$) of Chad in 1995 to that in 1999?
Your answer should be very brief. 0.69. What is the ratio of the Amount (in current US$) of El Salvador in 1995 to that in 1999?
Your response must be concise. 0.18. What is the ratio of the Amount (in current US$) in Vietnam in 1995 to that in 1999?
Ensure brevity in your answer.  10.04. What is the ratio of the Amount (in current US$) of Chad in 1995 to that in 2000?
Ensure brevity in your answer.  1.76. What is the ratio of the Amount (in current US$) of El Salvador in 1995 to that in 2000?
Offer a very short reply. 0.19. What is the ratio of the Amount (in current US$) of Vietnam in 1995 to that in 2000?
Your response must be concise. 1.24. What is the ratio of the Amount (in current US$) of Chad in 1995 to that in 2001?
Offer a very short reply. 1.27. What is the ratio of the Amount (in current US$) in El Salvador in 1995 to that in 2001?
Make the answer very short. 0.07. What is the ratio of the Amount (in current US$) in Chad in 1996 to that in 1997?
Give a very brief answer. 1.26. What is the ratio of the Amount (in current US$) of El Salvador in 1996 to that in 1997?
Provide a short and direct response. 1.43. What is the ratio of the Amount (in current US$) in Vietnam in 1996 to that in 1997?
Keep it short and to the point. 0.52. What is the ratio of the Amount (in current US$) of Chad in 1996 to that in 1998?
Your answer should be compact. 2.47. What is the ratio of the Amount (in current US$) in El Salvador in 1996 to that in 1998?
Offer a very short reply. 10.46. What is the ratio of the Amount (in current US$) of Vietnam in 1996 to that in 1998?
Ensure brevity in your answer.  0.54. What is the ratio of the Amount (in current US$) of Chad in 1996 to that in 1999?
Your response must be concise. 1.14. What is the ratio of the Amount (in current US$) in El Salvador in 1996 to that in 1999?
Ensure brevity in your answer.  1.33. What is the ratio of the Amount (in current US$) of Vietnam in 1996 to that in 1999?
Your response must be concise. 8.83. What is the ratio of the Amount (in current US$) of Chad in 1996 to that in 2000?
Your response must be concise. 2.88. What is the ratio of the Amount (in current US$) in El Salvador in 1996 to that in 2000?
Provide a short and direct response. 1.42. What is the ratio of the Amount (in current US$) in Vietnam in 1996 to that in 2000?
Your response must be concise. 1.09. What is the ratio of the Amount (in current US$) of Chad in 1996 to that in 2001?
Make the answer very short. 2.08. What is the ratio of the Amount (in current US$) in El Salvador in 1996 to that in 2001?
Your answer should be very brief. 0.49. What is the ratio of the Amount (in current US$) in Vietnam in 1996 to that in 2001?
Keep it short and to the point. 0.91. What is the ratio of the Amount (in current US$) of Chad in 1997 to that in 1998?
Your answer should be very brief. 1.95. What is the ratio of the Amount (in current US$) in El Salvador in 1997 to that in 1998?
Ensure brevity in your answer.  7.3. What is the ratio of the Amount (in current US$) in Vietnam in 1997 to that in 1998?
Make the answer very short. 1.03. What is the ratio of the Amount (in current US$) of Chad in 1997 to that in 1999?
Provide a succinct answer. 0.9. What is the ratio of the Amount (in current US$) of El Salvador in 1997 to that in 1999?
Give a very brief answer. 0.93. What is the ratio of the Amount (in current US$) in Vietnam in 1997 to that in 1999?
Your answer should be very brief. 16.99. What is the ratio of the Amount (in current US$) of Chad in 1997 to that in 2000?
Give a very brief answer. 2.28. What is the ratio of the Amount (in current US$) in Vietnam in 1997 to that in 2000?
Your answer should be very brief. 2.09. What is the ratio of the Amount (in current US$) of Chad in 1997 to that in 2001?
Your answer should be very brief. 1.65. What is the ratio of the Amount (in current US$) in El Salvador in 1997 to that in 2001?
Provide a succinct answer. 0.34. What is the ratio of the Amount (in current US$) of Vietnam in 1997 to that in 2001?
Your response must be concise. 1.76. What is the ratio of the Amount (in current US$) of Chad in 1998 to that in 1999?
Provide a succinct answer. 0.46. What is the ratio of the Amount (in current US$) in El Salvador in 1998 to that in 1999?
Offer a terse response. 0.13. What is the ratio of the Amount (in current US$) in Vietnam in 1998 to that in 1999?
Your response must be concise. 16.46. What is the ratio of the Amount (in current US$) of Chad in 1998 to that in 2000?
Your answer should be very brief. 1.17. What is the ratio of the Amount (in current US$) in El Salvador in 1998 to that in 2000?
Your answer should be very brief. 0.14. What is the ratio of the Amount (in current US$) in Jamaica in 1998 to that in 2000?
Offer a very short reply. 0.2. What is the ratio of the Amount (in current US$) of Vietnam in 1998 to that in 2000?
Offer a terse response. 2.02. What is the ratio of the Amount (in current US$) in Chad in 1998 to that in 2001?
Your answer should be very brief. 0.84. What is the ratio of the Amount (in current US$) in El Salvador in 1998 to that in 2001?
Ensure brevity in your answer.  0.05. What is the ratio of the Amount (in current US$) of Jamaica in 1998 to that in 2001?
Keep it short and to the point. 0.15. What is the ratio of the Amount (in current US$) in Vietnam in 1998 to that in 2001?
Your answer should be very brief. 1.7. What is the ratio of the Amount (in current US$) in Chad in 1999 to that in 2000?
Your answer should be compact. 2.54. What is the ratio of the Amount (in current US$) of El Salvador in 1999 to that in 2000?
Provide a succinct answer. 1.07. What is the ratio of the Amount (in current US$) of Vietnam in 1999 to that in 2000?
Your response must be concise. 0.12. What is the ratio of the Amount (in current US$) in Chad in 1999 to that in 2001?
Offer a very short reply. 1.83. What is the ratio of the Amount (in current US$) in El Salvador in 1999 to that in 2001?
Give a very brief answer. 0.37. What is the ratio of the Amount (in current US$) of Vietnam in 1999 to that in 2001?
Give a very brief answer. 0.1. What is the ratio of the Amount (in current US$) in Chad in 2000 to that in 2001?
Offer a very short reply. 0.72. What is the ratio of the Amount (in current US$) in El Salvador in 2000 to that in 2001?
Your answer should be compact. 0.34. What is the ratio of the Amount (in current US$) in Jamaica in 2000 to that in 2001?
Offer a very short reply. 0.75. What is the ratio of the Amount (in current US$) of Vietnam in 2000 to that in 2001?
Give a very brief answer. 0.84. What is the difference between the highest and the second highest Amount (in current US$) in Chad?
Make the answer very short. 1.12e+07. What is the difference between the highest and the second highest Amount (in current US$) in El Salvador?
Give a very brief answer. 3.13e+08. What is the difference between the highest and the second highest Amount (in current US$) of Jamaica?
Your response must be concise. 1.58e+08. What is the difference between the highest and the second highest Amount (in current US$) of Vietnam?
Your answer should be very brief. 2.19e+07. What is the difference between the highest and the lowest Amount (in current US$) of Chad?
Your answer should be compact. 6.13e+07. What is the difference between the highest and the lowest Amount (in current US$) in El Salvador?
Your answer should be compact. 5.81e+08. What is the difference between the highest and the lowest Amount (in current US$) in Jamaica?
Offer a very short reply. 6.37e+08. What is the difference between the highest and the lowest Amount (in current US$) in Vietnam?
Keep it short and to the point. 6.59e+08. 